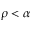Convert formula to latex. <formula><loc_0><loc_0><loc_500><loc_500>\rho < \alpha</formula> 